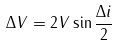<formula> <loc_0><loc_0><loc_500><loc_500>\Delta V = 2 V \sin \frac { \Delta i } { 2 }</formula> 